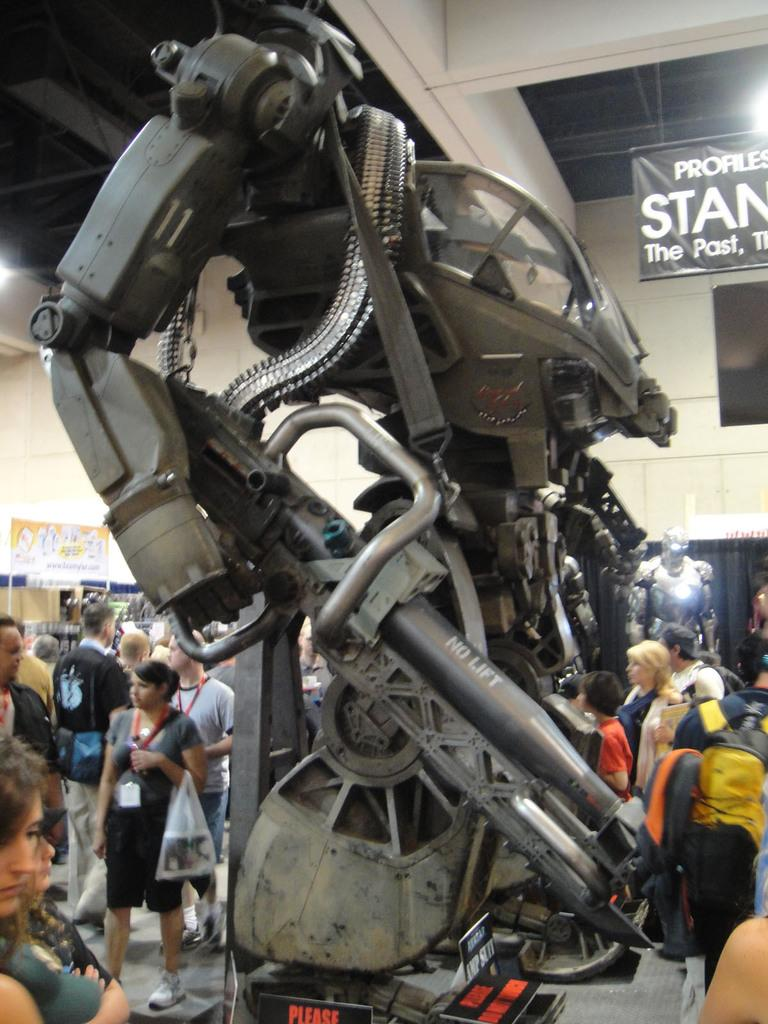What is the main subject in the image? There is a robot in the image. What else can be seen in the image besides the robot? There is a group of people standing on the ground. What is visible in the background of the image? There is a wall, banners, lights, and other objects visible in the background of the image. What type of nut is being used as a table by the robot in the image? There is no nut or table present in the image; the robot is not interacting with any such objects. 